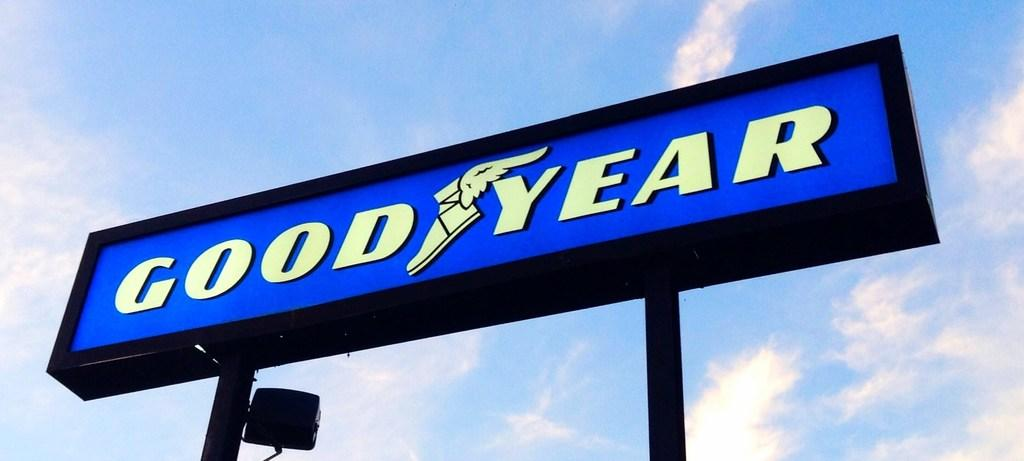<image>
Render a clear and concise summary of the photo. A lit up Good Year sign on a partly cloudy day. 